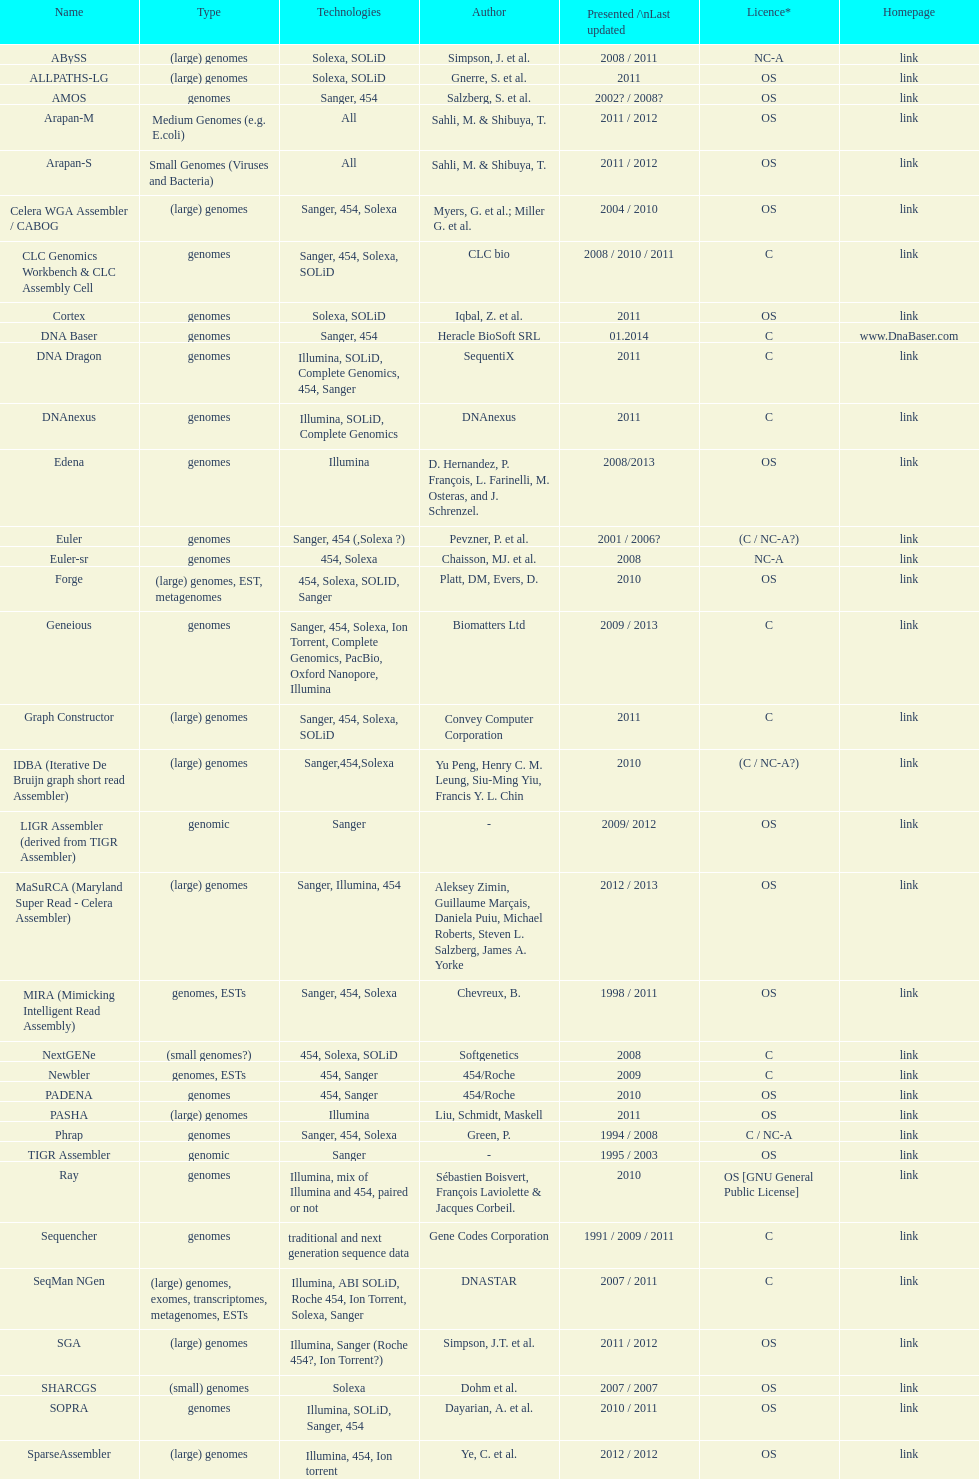How many instances were there of sahi, m. & shilbuya, t. being cited as co-authors? 2. 